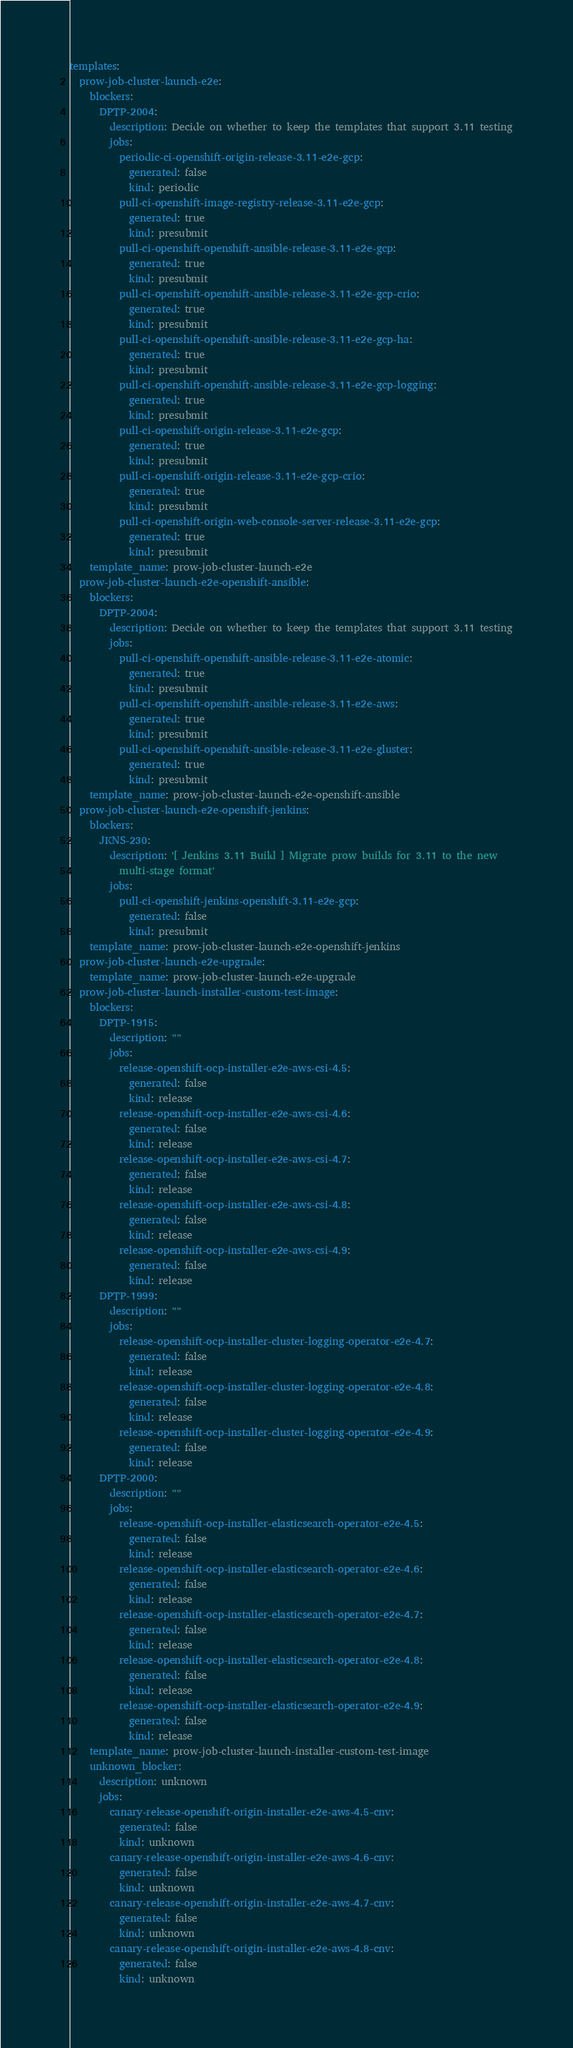<code> <loc_0><loc_0><loc_500><loc_500><_YAML_>templates:
  prow-job-cluster-launch-e2e:
    blockers:
      DPTP-2004:
        description: Decide on whether to keep the templates that support 3.11 testing
        jobs:
          periodic-ci-openshift-origin-release-3.11-e2e-gcp:
            generated: false
            kind: periodic
          pull-ci-openshift-image-registry-release-3.11-e2e-gcp:
            generated: true
            kind: presubmit
          pull-ci-openshift-openshift-ansible-release-3.11-e2e-gcp:
            generated: true
            kind: presubmit
          pull-ci-openshift-openshift-ansible-release-3.11-e2e-gcp-crio:
            generated: true
            kind: presubmit
          pull-ci-openshift-openshift-ansible-release-3.11-e2e-gcp-ha:
            generated: true
            kind: presubmit
          pull-ci-openshift-openshift-ansible-release-3.11-e2e-gcp-logging:
            generated: true
            kind: presubmit
          pull-ci-openshift-origin-release-3.11-e2e-gcp:
            generated: true
            kind: presubmit
          pull-ci-openshift-origin-release-3.11-e2e-gcp-crio:
            generated: true
            kind: presubmit
          pull-ci-openshift-origin-web-console-server-release-3.11-e2e-gcp:
            generated: true
            kind: presubmit
    template_name: prow-job-cluster-launch-e2e
  prow-job-cluster-launch-e2e-openshift-ansible:
    blockers:
      DPTP-2004:
        description: Decide on whether to keep the templates that support 3.11 testing
        jobs:
          pull-ci-openshift-openshift-ansible-release-3.11-e2e-atomic:
            generated: true
            kind: presubmit
          pull-ci-openshift-openshift-ansible-release-3.11-e2e-aws:
            generated: true
            kind: presubmit
          pull-ci-openshift-openshift-ansible-release-3.11-e2e-gluster:
            generated: true
            kind: presubmit
    template_name: prow-job-cluster-launch-e2e-openshift-ansible
  prow-job-cluster-launch-e2e-openshift-jenkins:
    blockers:
      JKNS-230:
        description: '[ Jenkins 3.11 Build ] Migrate prow builds for 3.11 to the new
          multi-stage format'
        jobs:
          pull-ci-openshift-jenkins-openshift-3.11-e2e-gcp:
            generated: false
            kind: presubmit
    template_name: prow-job-cluster-launch-e2e-openshift-jenkins
  prow-job-cluster-launch-e2e-upgrade:
    template_name: prow-job-cluster-launch-e2e-upgrade
  prow-job-cluster-launch-installer-custom-test-image:
    blockers:
      DPTP-1915:
        description: ""
        jobs:
          release-openshift-ocp-installer-e2e-aws-csi-4.5:
            generated: false
            kind: release
          release-openshift-ocp-installer-e2e-aws-csi-4.6:
            generated: false
            kind: release
          release-openshift-ocp-installer-e2e-aws-csi-4.7:
            generated: false
            kind: release
          release-openshift-ocp-installer-e2e-aws-csi-4.8:
            generated: false
            kind: release
          release-openshift-ocp-installer-e2e-aws-csi-4.9:
            generated: false
            kind: release
      DPTP-1999:
        description: ""
        jobs:
          release-openshift-ocp-installer-cluster-logging-operator-e2e-4.7:
            generated: false
            kind: release
          release-openshift-ocp-installer-cluster-logging-operator-e2e-4.8:
            generated: false
            kind: release
          release-openshift-ocp-installer-cluster-logging-operator-e2e-4.9:
            generated: false
            kind: release
      DPTP-2000:
        description: ""
        jobs:
          release-openshift-ocp-installer-elasticsearch-operator-e2e-4.5:
            generated: false
            kind: release
          release-openshift-ocp-installer-elasticsearch-operator-e2e-4.6:
            generated: false
            kind: release
          release-openshift-ocp-installer-elasticsearch-operator-e2e-4.7:
            generated: false
            kind: release
          release-openshift-ocp-installer-elasticsearch-operator-e2e-4.8:
            generated: false
            kind: release
          release-openshift-ocp-installer-elasticsearch-operator-e2e-4.9:
            generated: false
            kind: release
    template_name: prow-job-cluster-launch-installer-custom-test-image
    unknown_blocker:
      description: unknown
      jobs:
        canary-release-openshift-origin-installer-e2e-aws-4.5-cnv:
          generated: false
          kind: unknown
        canary-release-openshift-origin-installer-e2e-aws-4.6-cnv:
          generated: false
          kind: unknown
        canary-release-openshift-origin-installer-e2e-aws-4.7-cnv:
          generated: false
          kind: unknown
        canary-release-openshift-origin-installer-e2e-aws-4.8-cnv:
          generated: false
          kind: unknown</code> 